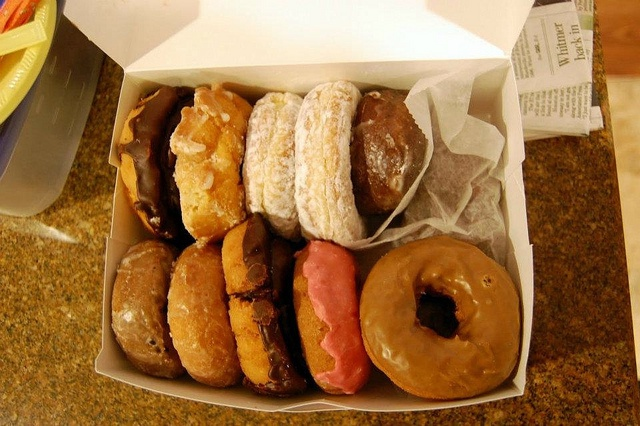Describe the objects in this image and their specific colors. I can see dining table in brown, maroon, ivory, tan, and black tones, donut in navy, brown, maroon, and black tones, donut in navy, black, maroon, and orange tones, donut in navy and tan tones, and donut in navy, red, and orange tones in this image. 